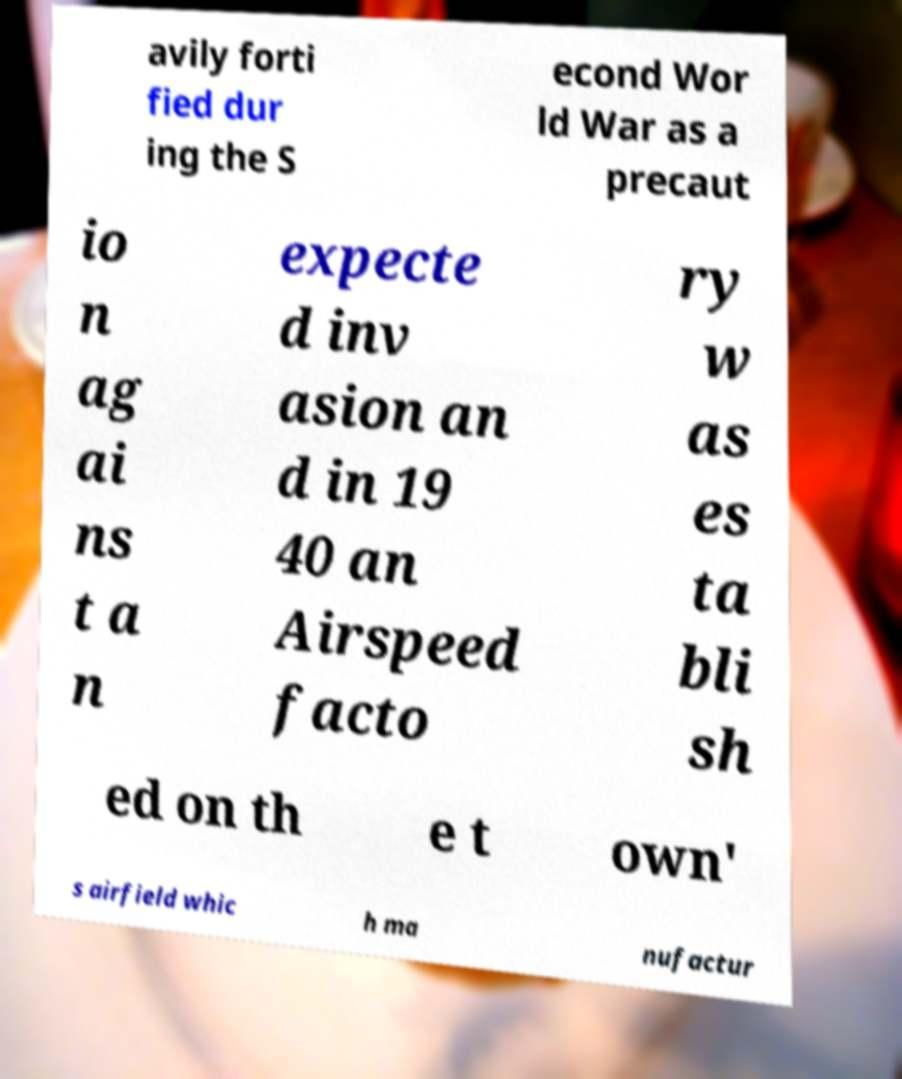Can you accurately transcribe the text from the provided image for me? avily forti fied dur ing the S econd Wor ld War as a precaut io n ag ai ns t a n expecte d inv asion an d in 19 40 an Airspeed facto ry w as es ta bli sh ed on th e t own' s airfield whic h ma nufactur 